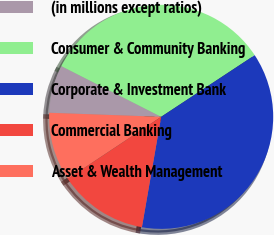<chart> <loc_0><loc_0><loc_500><loc_500><pie_chart><fcel>(in millions except ratios)<fcel>Consumer & Community Banking<fcel>Corporate & Investment Bank<fcel>Commercial Banking<fcel>Asset & Wealth Management<nl><fcel>6.9%<fcel>33.25%<fcel>37.02%<fcel>12.92%<fcel>9.91%<nl></chart> 